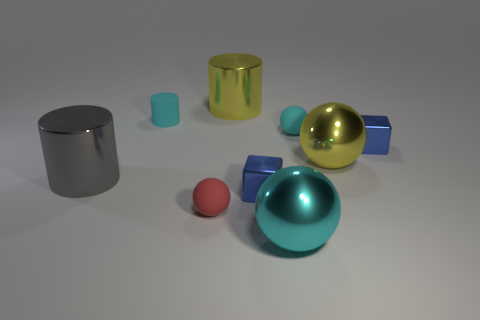There is a cylinder that is both in front of the yellow metal cylinder and right of the large gray object; what size is it?
Make the answer very short. Small. How many other objects are the same color as the small cylinder?
Provide a short and direct response. 2. Does the small cylinder have the same material as the large cylinder that is on the left side of the yellow metallic cylinder?
Your response must be concise. No. What number of objects are either tiny rubber objects that are behind the tiny cyan sphere or red spheres?
Your response must be concise. 2. What is the shape of the thing that is to the right of the big gray metal cylinder and left of the red matte ball?
Offer a terse response. Cylinder. Is there any other thing that has the same size as the red object?
Give a very brief answer. Yes. The red sphere that is made of the same material as the tiny cylinder is what size?
Offer a very short reply. Small. What number of things are tiny balls on the right side of the big yellow cylinder or shiny objects that are to the right of the gray thing?
Your answer should be very brief. 6. Do the metallic sphere behind the cyan shiny object and the gray thing have the same size?
Make the answer very short. Yes. The large shiny ball that is on the right side of the cyan shiny thing is what color?
Provide a succinct answer. Yellow. 